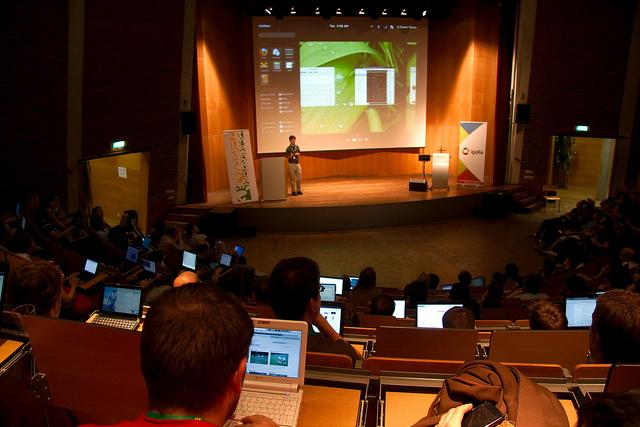What type of classroom could this be called? Please explain your reasoning. stadium. The seats are arranged in theater format. 